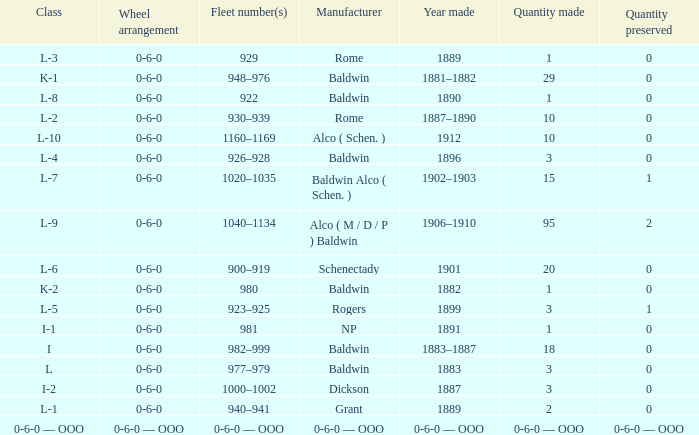Which Class has a Quantity made of 29? K-1. 